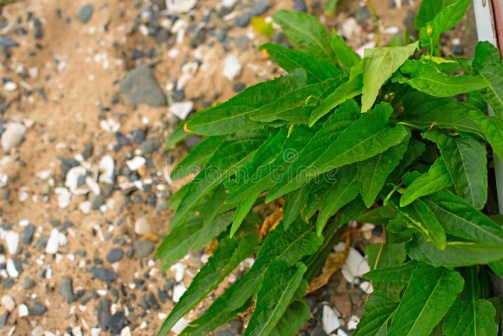How might this scene change through the seasons? This scene would transform dramatically with the changing seasons. In spring, the plant might show new, vibrant green growth, bursting with energy after the winter dormancy, while small wildflowers might dot the rocky ground, adding splashes of color. In summer, the leaves would likely be at their fullest, thriving under the warm sun, while the soil and rocks might become dry and dusty. Autumn could bring a change in the plant's appearance, with leaves turning different shades or new plants growing around it as the weather cools. Finally, in winter, the rugged landscape might be covered in a light dusting of snow, or frost might cling to the rocks and plant leaves, creating a stark and serene beauty. Each season would bring its own unique charm, reflecting the ever-changing rhythms of the natural world. 